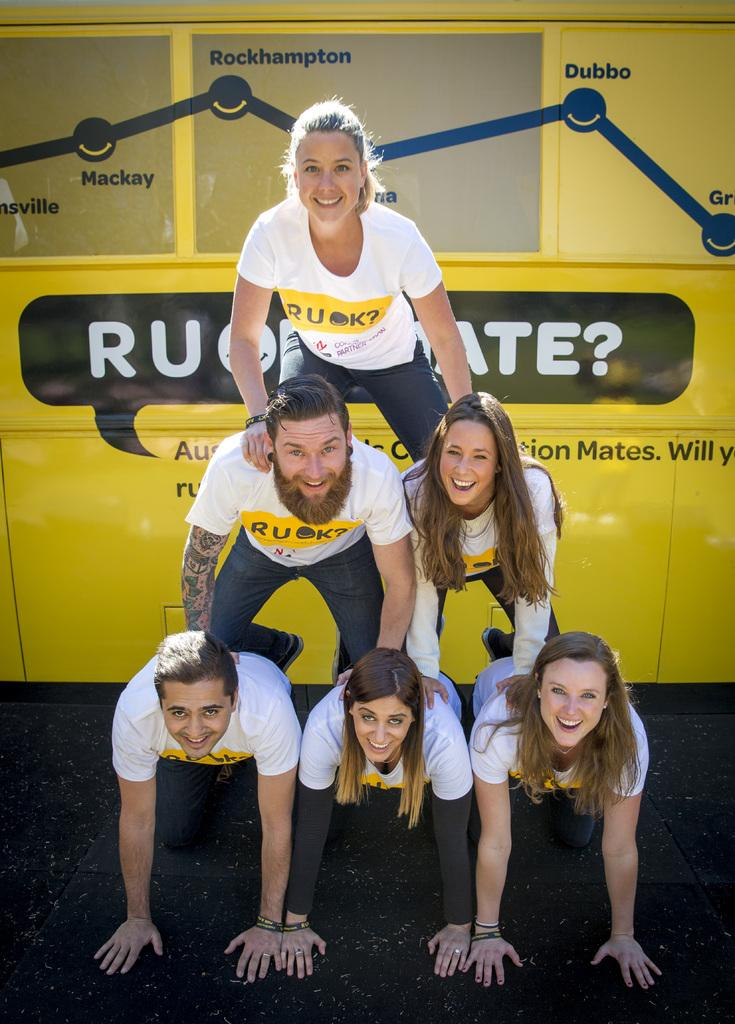Provide a one-sentence caption for the provided image. A group of people are forming a pyramid in front of a yellow object with the word Rockhampton above them. 